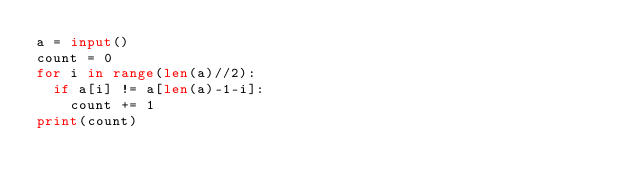<code> <loc_0><loc_0><loc_500><loc_500><_Python_>a = input()
count = 0
for i in range(len(a)//2):
  if a[i] != a[len(a)-1-i]:
    count += 1
print(count)</code> 